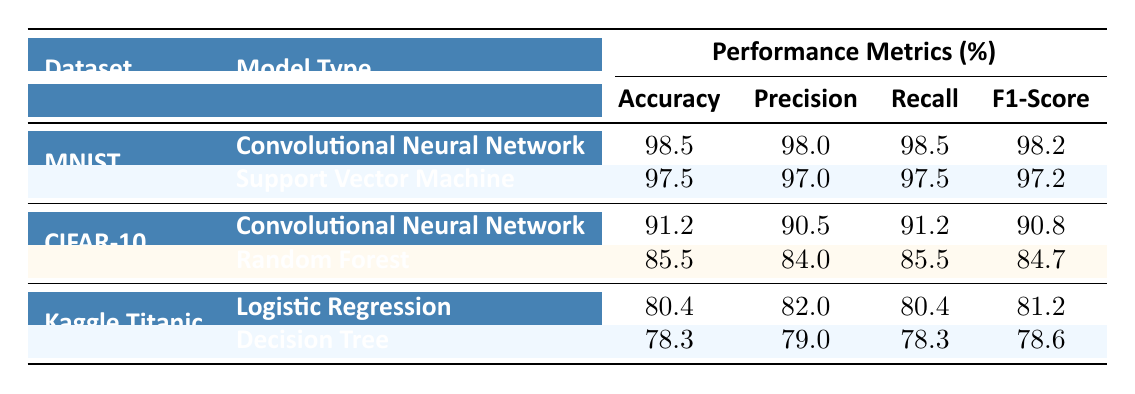What is the accuracy of the Convolutional Neural Network on the MNIST dataset? The accuracy value for the Convolutional Neural Network under the MNIST dataset is listed in the table, which states it is 98.5%.
Answer: 98.5% Which model type has the highest Recall in the CIFAR-10 dataset? From the table, we see that the Convolutional Neural Network has a Recall value of 91.2%, while the Random Forest has a Recall of 85.5%. Therefore, the highest Recall belongs to the Convolutional Neural Network.
Answer: Convolutional Neural Network What is the difference in F1-Score between Logistic Regression and Decision Tree on Kaggle Titanic? The F1-Score values for Logistic Regression and Decision Tree are 81.2% and 78.6% respectively. The difference is calculated as 81.2% - 78.6% = 2.6%.
Answer: 2.6% Is the Precision of the Support Vector Machine lower than that of the Decision Tree? The Precision of the Support Vector Machine is 97.0%, while the Precision of the Decision Tree is 79.0%. Since 97.0% > 79.0%, the statement is false.
Answer: No What is the average Accuracy of the models listed for the Kaggle Titanic dataset? The Accuracy values for Logistic Regression and Decision Tree are 80.4% and 78.3% respectively. The sum is (80.4 + 78.3) = 158.7%. To find the average, divide by the number of models (2): 158.7% / 2 = 79.35%.
Answer: 79.35% Which model type consistently performed better in terms of Accuracy across all datasets? By examining the table, the Convolutional Neural Network achieves the highest Accuracy of 98.5% on MNIST, 91.2% on CIFAR-10, and is the only model type listed for both datasets in question. The other models do not consistently outperform it.
Answer: Convolutional Neural Network What is the Recall of the Random Forest model in the CIFAR-10 dataset? The Recall value for the Random Forest model under the CIFAR-10 dataset is explicitly stated in the table as 85.5%.
Answer: 85.5% 